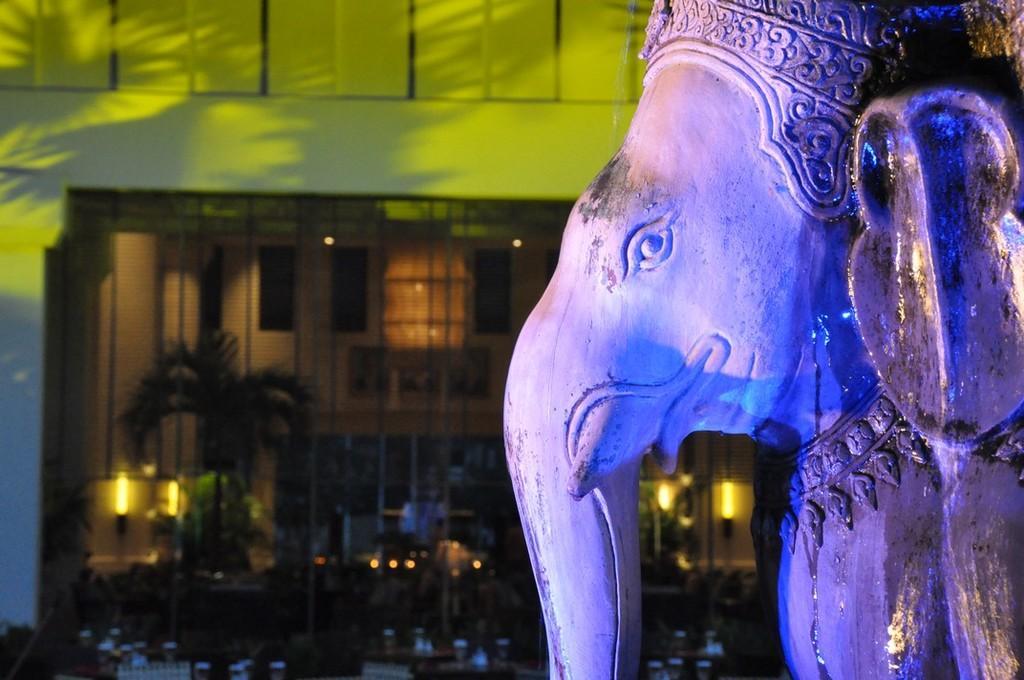In one or two sentences, can you explain what this image depicts? It's a statue of a lord Ganesha in the left side it's a building. 